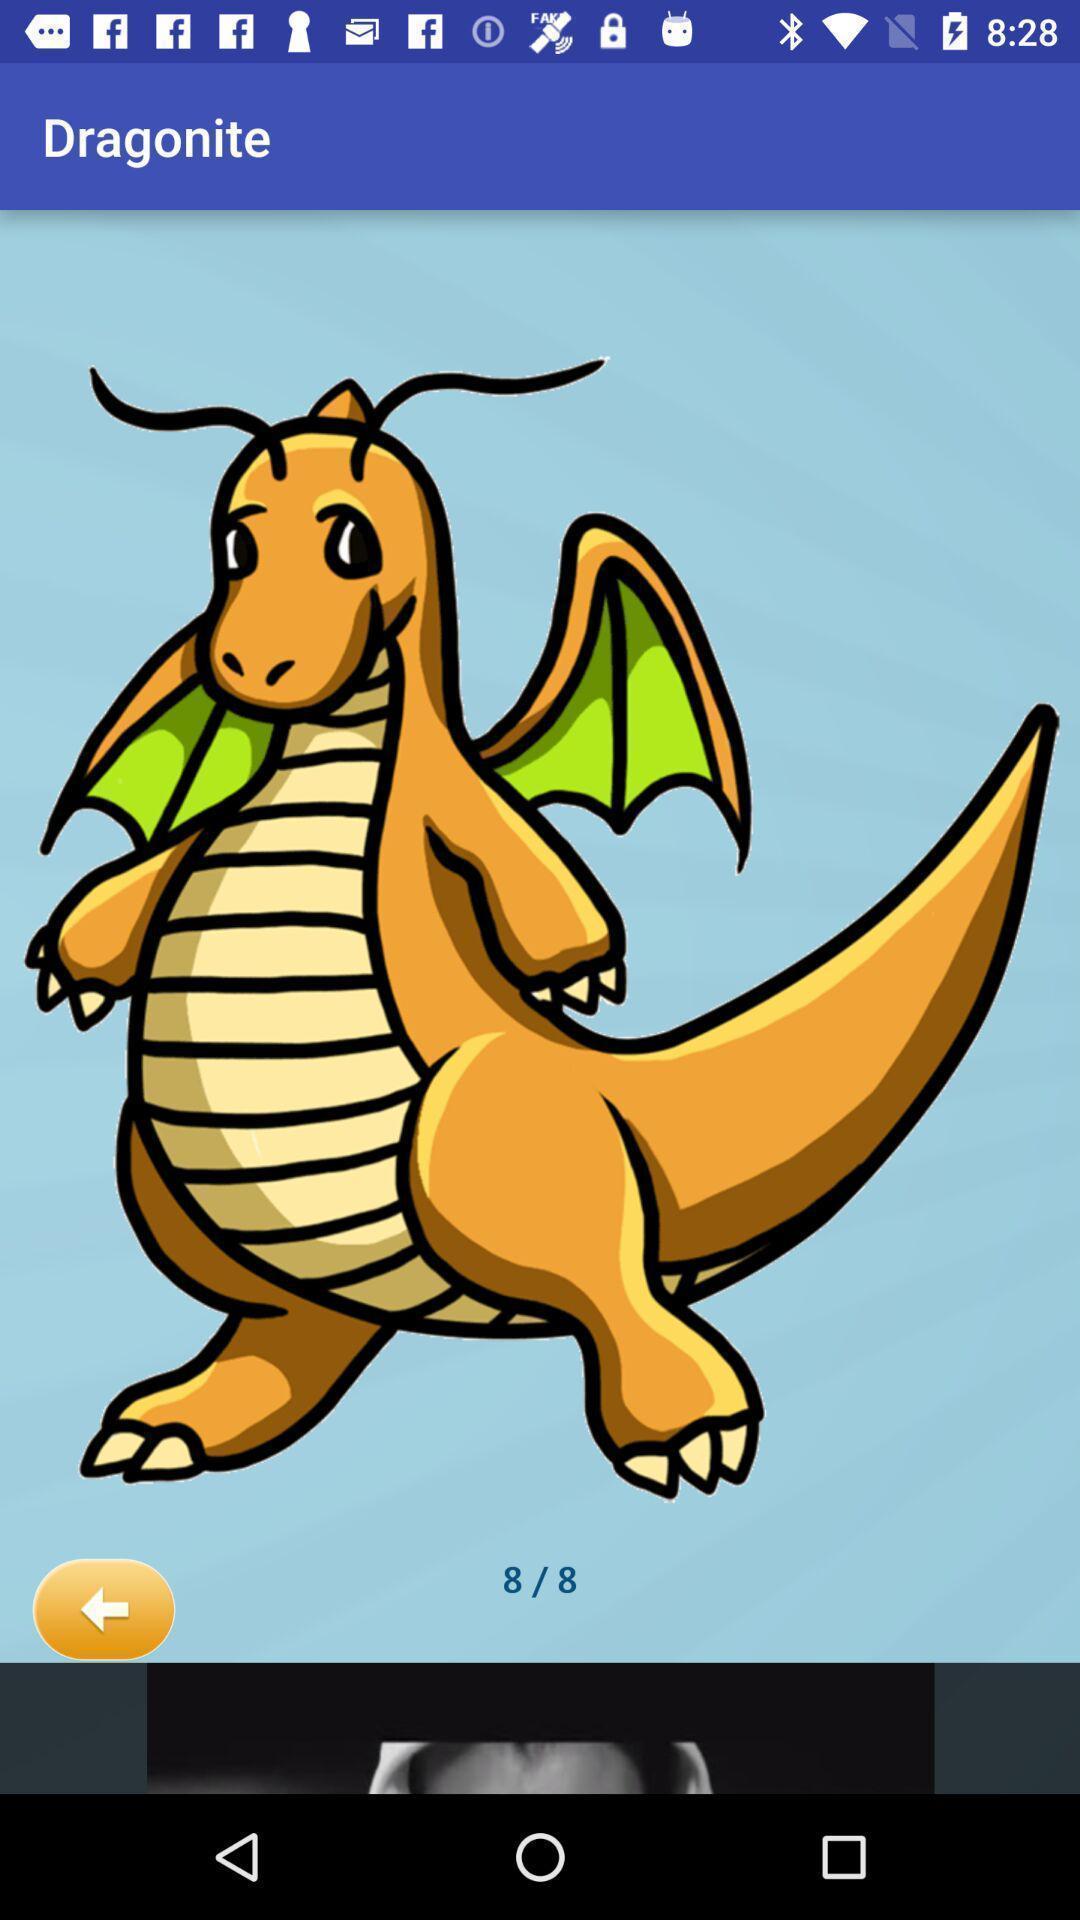What details can you identify in this image? Page displaying the image of a dragon. 